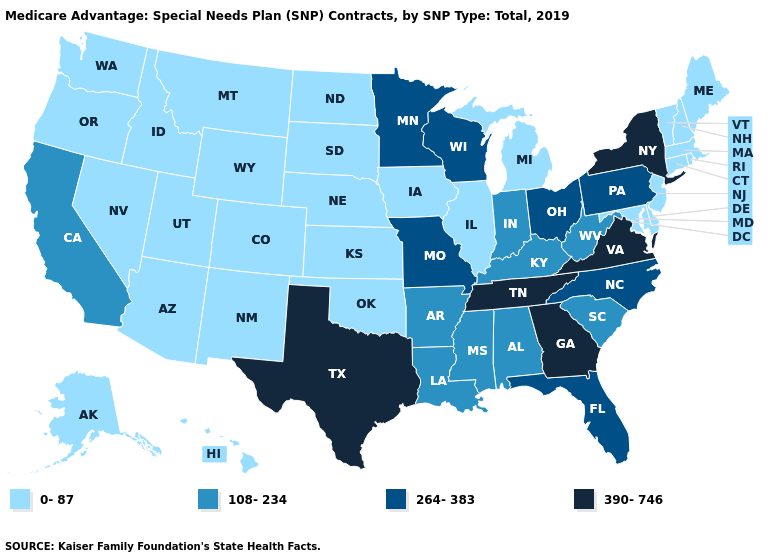Does Mississippi have a higher value than West Virginia?
Give a very brief answer. No. Is the legend a continuous bar?
Concise answer only. No. Does the map have missing data?
Quick response, please. No. Does Texas have the highest value in the USA?
Answer briefly. Yes. Which states have the lowest value in the USA?
Give a very brief answer. Alaska, Arizona, Colorado, Connecticut, Delaware, Hawaii, Idaho, Illinois, Iowa, Kansas, Maine, Maryland, Massachusetts, Michigan, Montana, Nebraska, Nevada, New Hampshire, New Jersey, New Mexico, North Dakota, Oklahoma, Oregon, Rhode Island, South Dakota, Utah, Vermont, Washington, Wyoming. What is the lowest value in the West?
Quick response, please. 0-87. Name the states that have a value in the range 264-383?
Answer briefly. Florida, Minnesota, Missouri, North Carolina, Ohio, Pennsylvania, Wisconsin. Name the states that have a value in the range 390-746?
Concise answer only. Georgia, New York, Tennessee, Texas, Virginia. Does the map have missing data?
Give a very brief answer. No. Name the states that have a value in the range 264-383?
Give a very brief answer. Florida, Minnesota, Missouri, North Carolina, Ohio, Pennsylvania, Wisconsin. What is the value of Utah?
Keep it brief. 0-87. Is the legend a continuous bar?
Give a very brief answer. No. Which states have the lowest value in the West?
Keep it brief. Alaska, Arizona, Colorado, Hawaii, Idaho, Montana, Nevada, New Mexico, Oregon, Utah, Washington, Wyoming. Does Florida have the lowest value in the USA?
Give a very brief answer. No. What is the value of Colorado?
Be succinct. 0-87. 